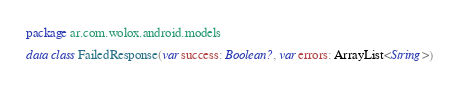Convert code to text. <code><loc_0><loc_0><loc_500><loc_500><_Kotlin_>package ar.com.wolox.android.models

data class FailedResponse(var success: Boolean?, var errors: ArrayList<String>)</code> 